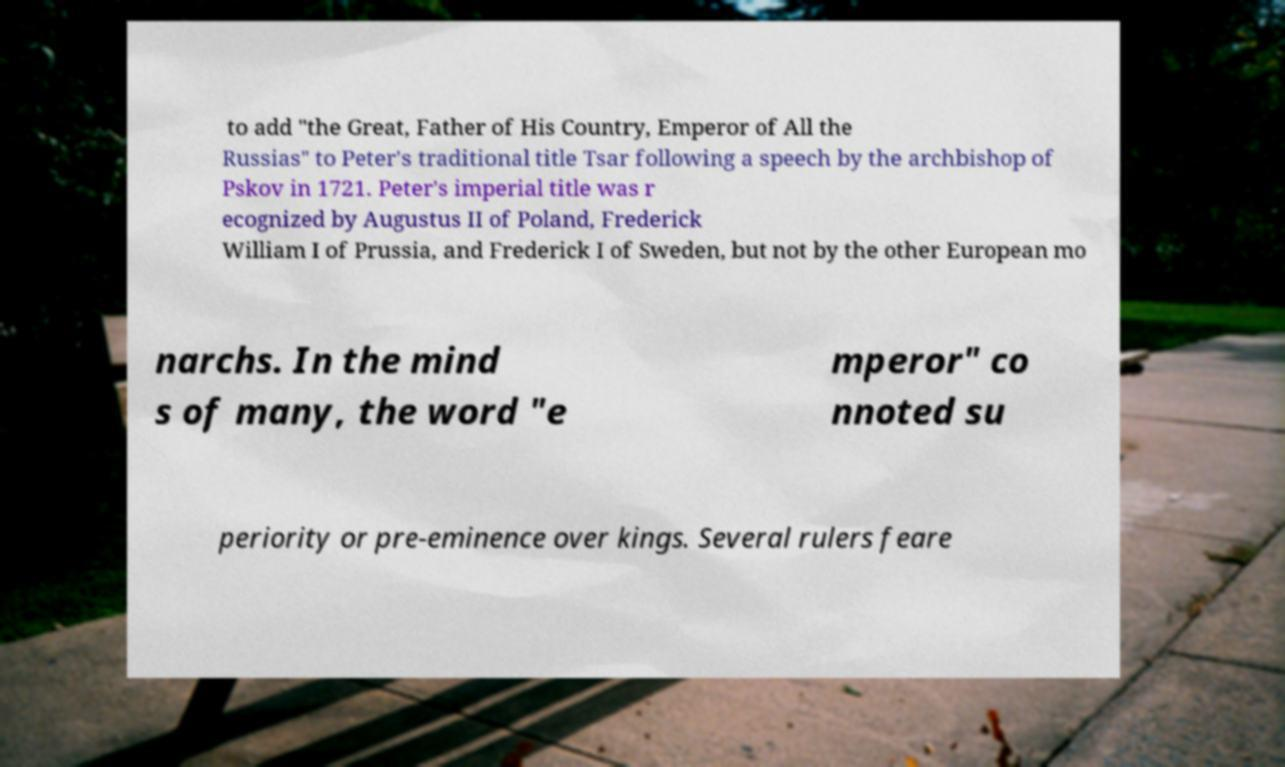Can you read and provide the text displayed in the image?This photo seems to have some interesting text. Can you extract and type it out for me? to add "the Great, Father of His Country, Emperor of All the Russias" to Peter's traditional title Tsar following a speech by the archbishop of Pskov in 1721. Peter's imperial title was r ecognized by Augustus II of Poland, Frederick William I of Prussia, and Frederick I of Sweden, but not by the other European mo narchs. In the mind s of many, the word "e mperor" co nnoted su periority or pre-eminence over kings. Several rulers feare 